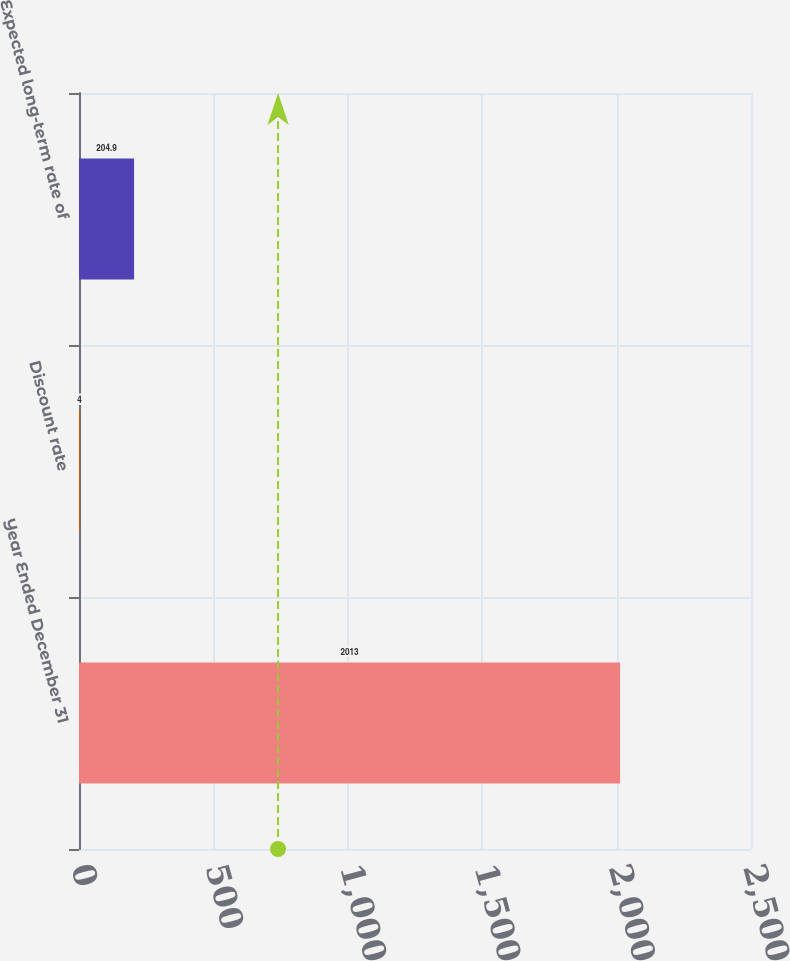Convert chart to OTSL. <chart><loc_0><loc_0><loc_500><loc_500><bar_chart><fcel>Year Ended December 31<fcel>Discount rate<fcel>Expected long-term rate of<nl><fcel>2013<fcel>4<fcel>204.9<nl></chart> 